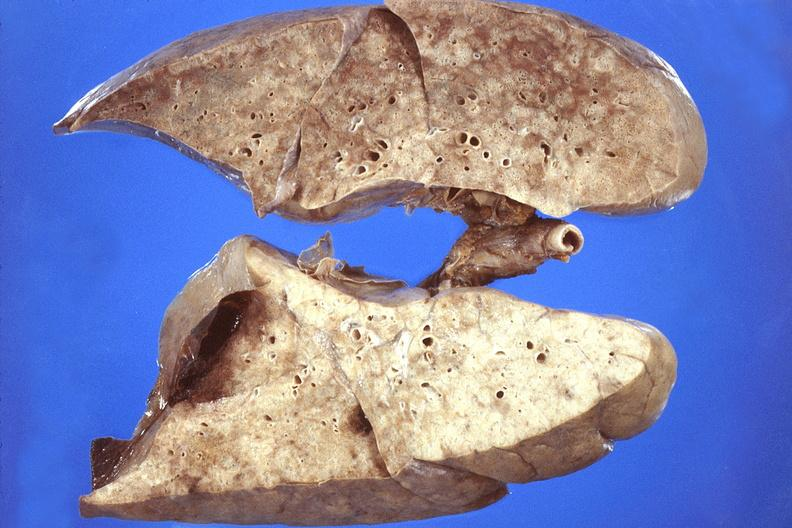s respiratory present?
Answer the question using a single word or phrase. Yes 